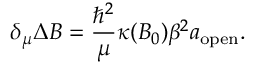Convert formula to latex. <formula><loc_0><loc_0><loc_500><loc_500>\delta _ { \mu } \Delta B = \frac { \hbar { ^ } { 2 } } { \mu } \kappa ( B _ { 0 } ) \beta ^ { 2 } a _ { o p e n } .</formula> 